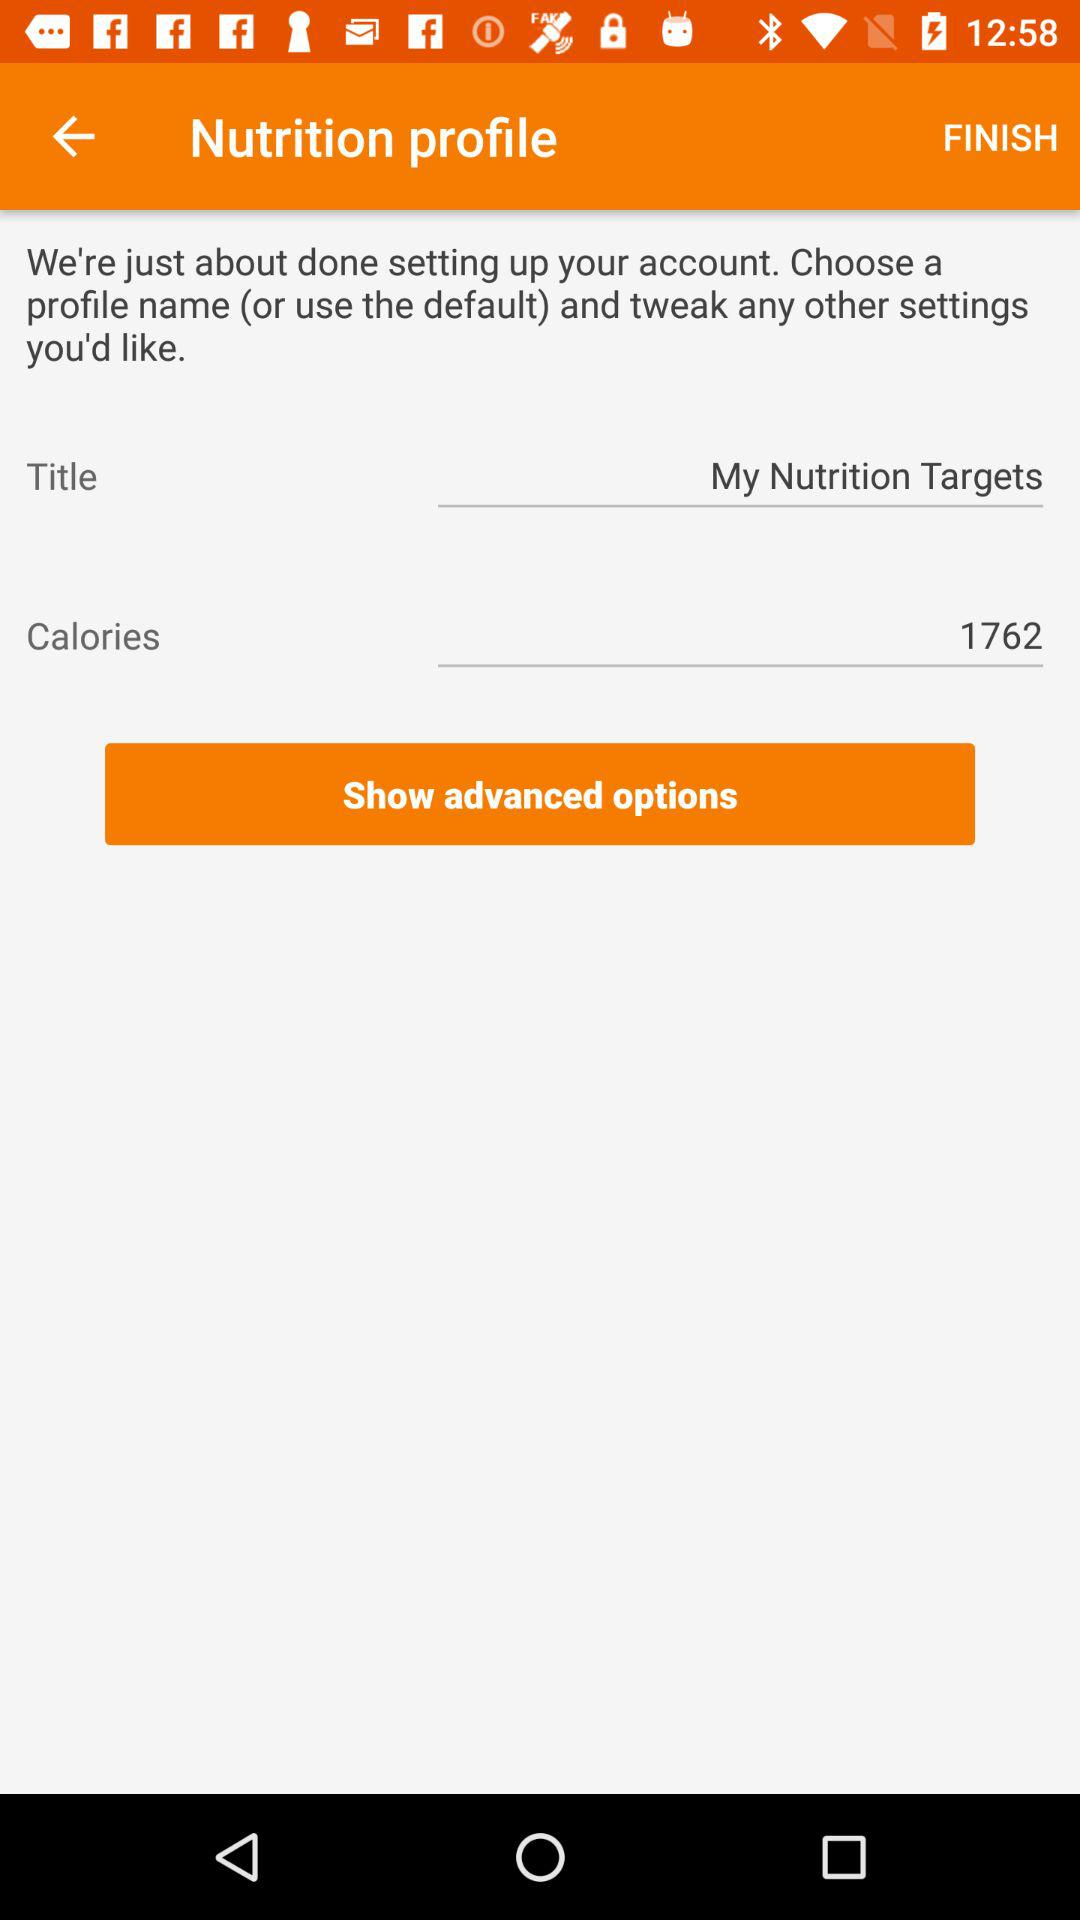How many grams of fat is the user's goal?
When the provided information is insufficient, respond with <no answer>. <no answer> 